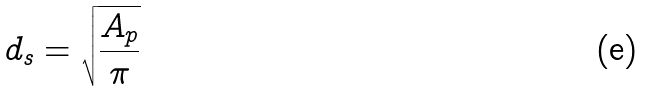Convert formula to latex. <formula><loc_0><loc_0><loc_500><loc_500>d _ { s } = \sqrt { \frac { A _ { p } } { \pi } }</formula> 